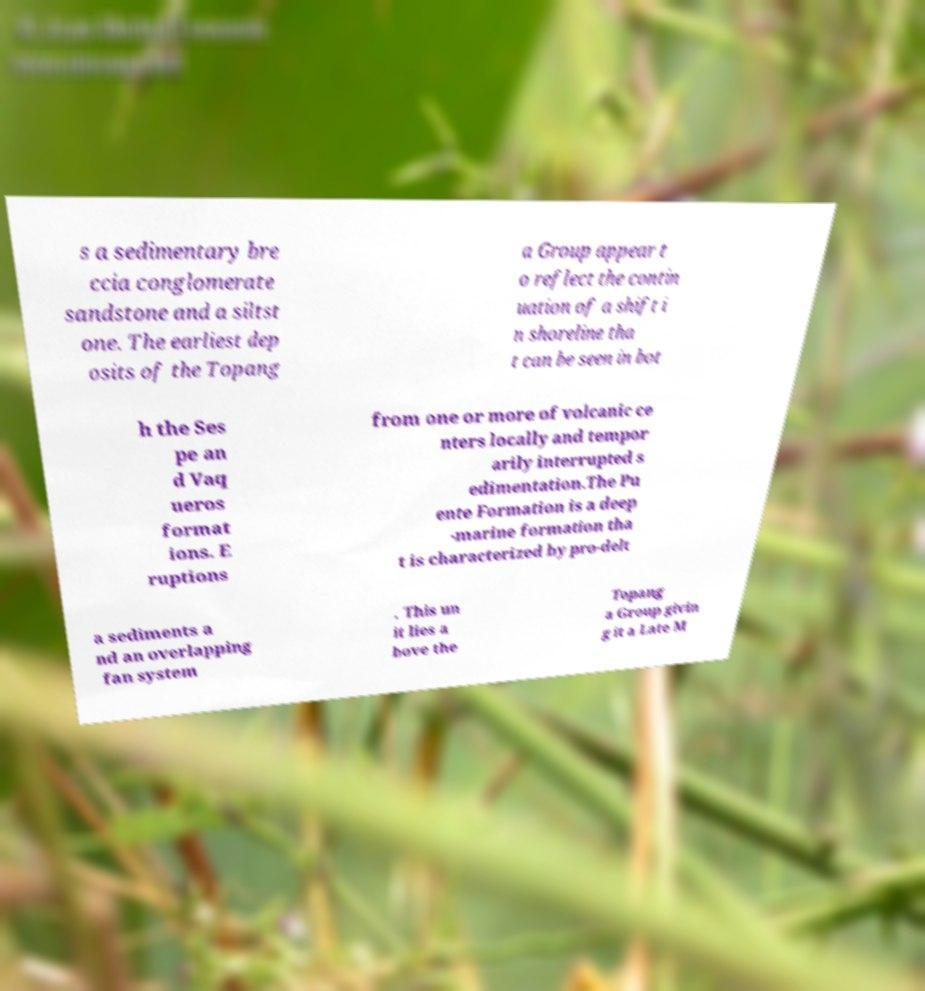Could you assist in decoding the text presented in this image and type it out clearly? s a sedimentary bre ccia conglomerate sandstone and a siltst one. The earliest dep osits of the Topang a Group appear t o reflect the contin uation of a shift i n shoreline tha t can be seen in bot h the Ses pe an d Vaq ueros format ions. E ruptions from one or more of volcanic ce nters locally and tempor arily interrupted s edimentation.The Pu ente Formation is a deep -marine formation tha t is characterized by pro-delt a sediments a nd an overlapping fan system . This un it lies a bove the Topang a Group givin g it a Late M 